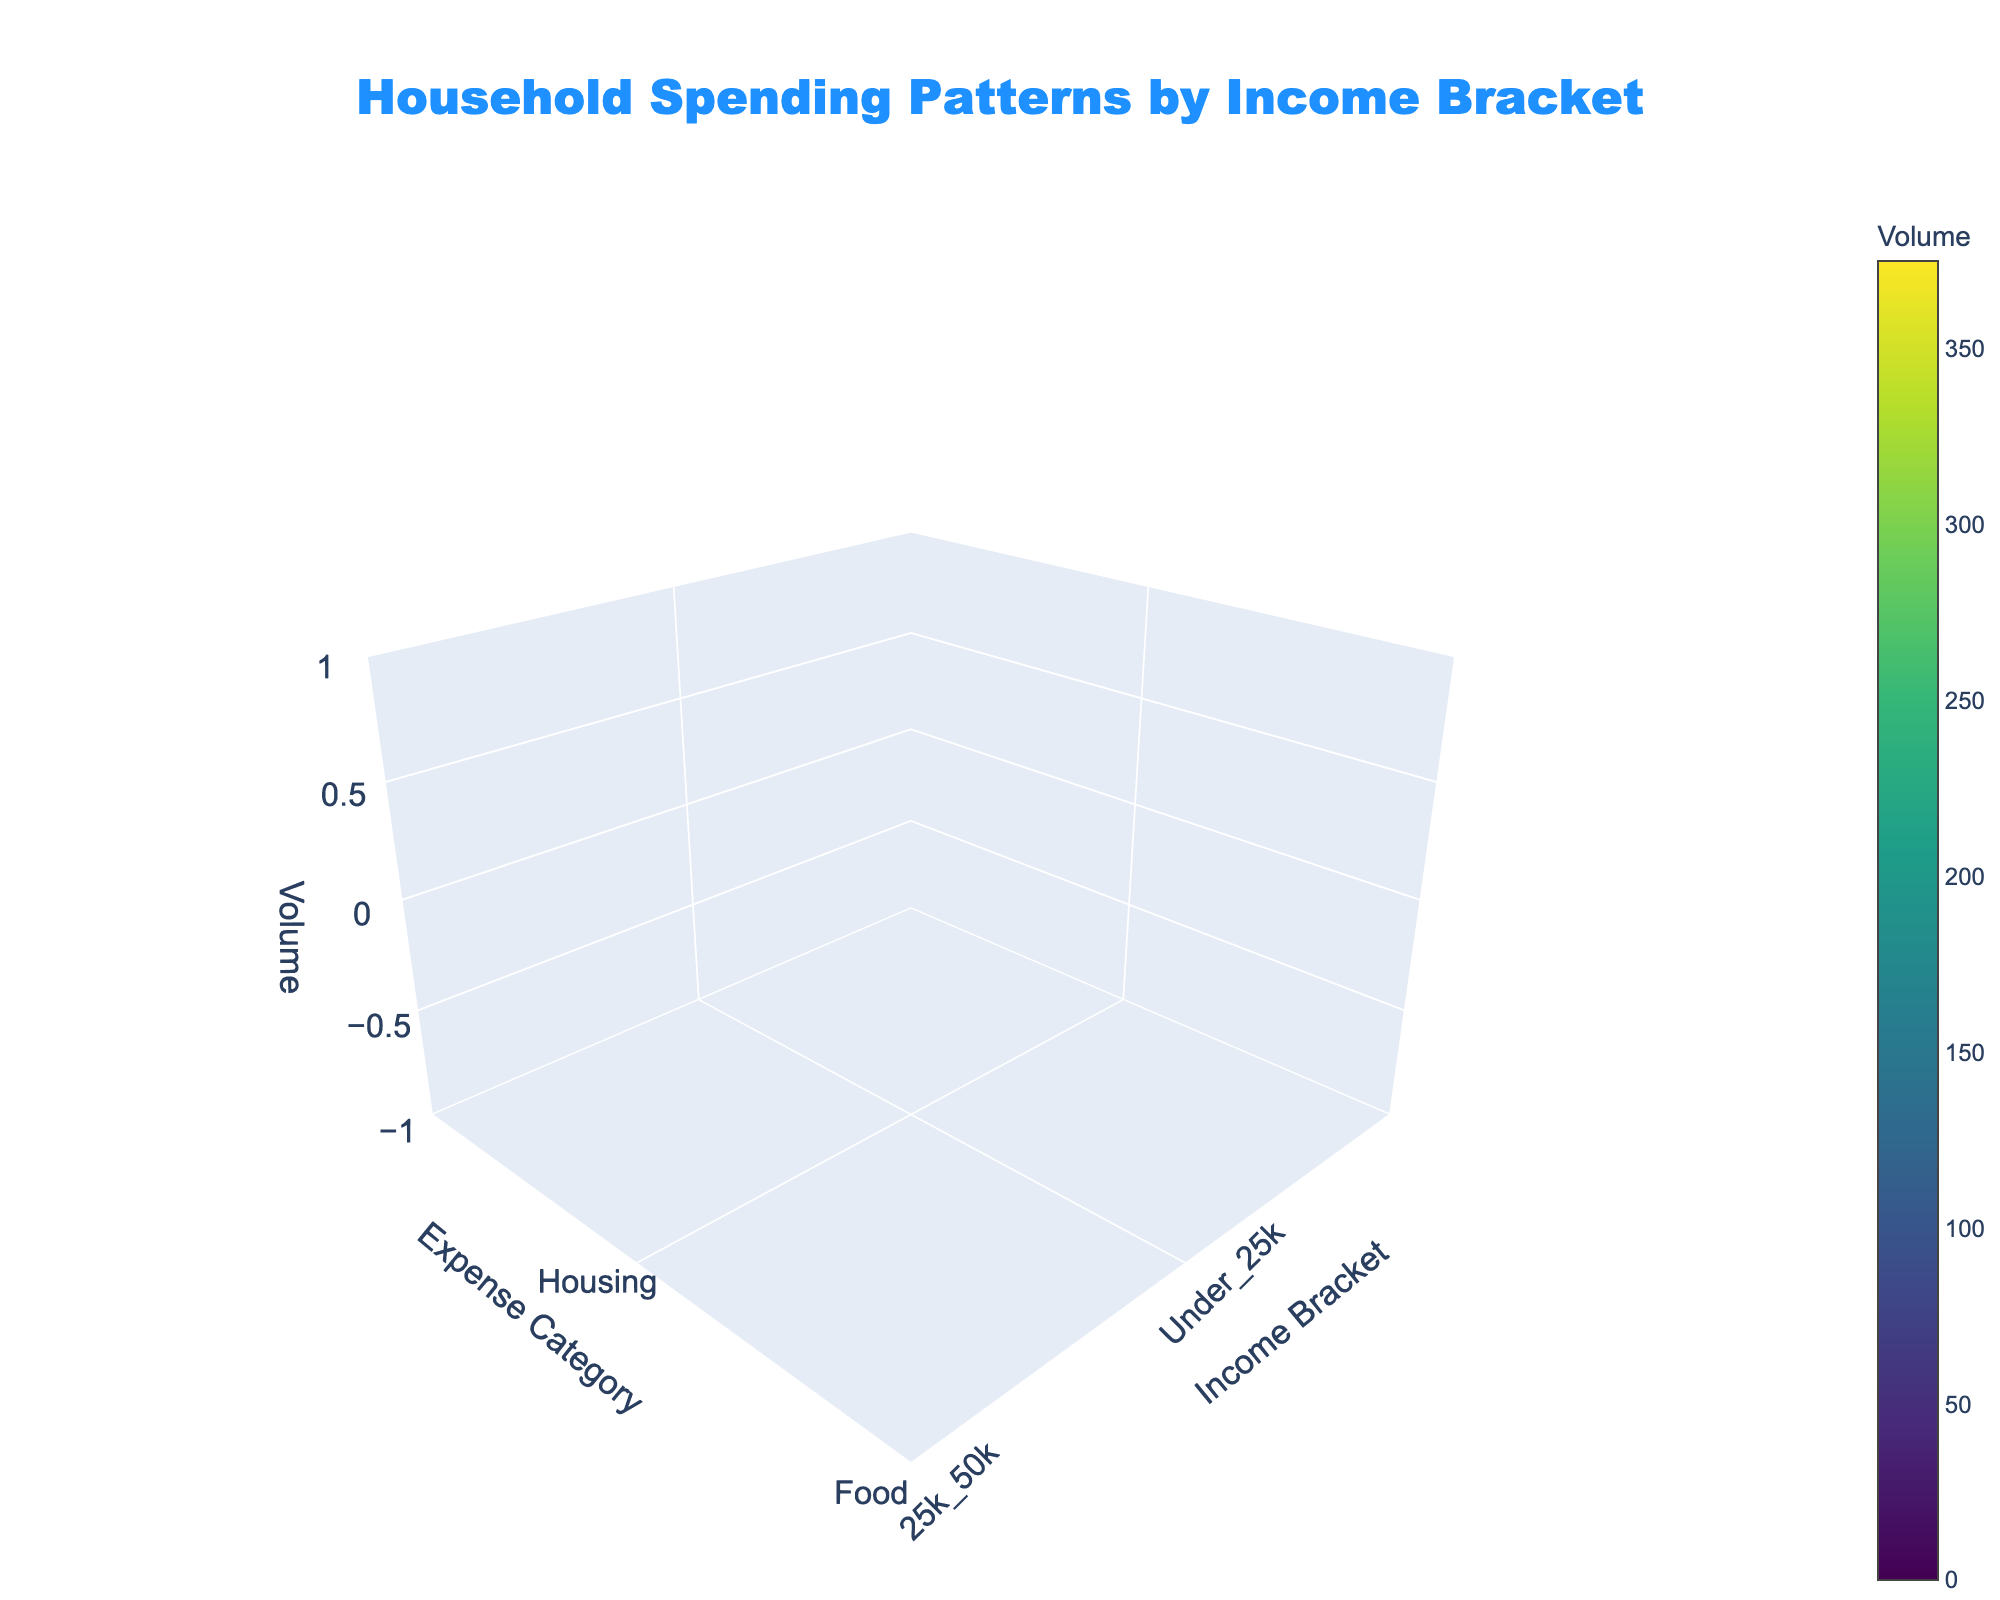What's the title of the figure? The title is usually found at the top of the figure. In this case, it reads "Household Spending Patterns by Income Bracket."
Answer: Household Spending Patterns by Income Bracket What does the colorbar title indicate? The colorbar provides a legend for interpreting the colors in the plot. The title "Volume" indicates it reflects the amount of volume spent on different expenses by income brackets.
Answer: Volume Which income bracket has the highest volume of expenditure on entertainment? By examining the volume data for entertainment across income brackets, the highest value of 375 appears in the "Over_100k" bracket.
Answer: Over_100k Which expense category has the smallest volume for the "Under_25k" income bracket? By checking the volume values for the "Under_25k" income bracket, "Entertainment" and "Savings" both have the smallest value of 14.
Answer: Entertainment, Savings What is the range of housing volumes across different income brackets? By looking at the volume values for "Housing" in all income brackets, they range from 100 (Under_25k) to 300 (Over_100k).
Answer: 100 to 300 What is the average volume of transportation expenses across all income brackets? Summing the values for "Transportation" across all income brackets gives 43 + 75 + 90 + 100 + 120 = 428. Dividing by the number of brackets (5) yields an average of 428 / 5 = 85.6.
Answer: 85.6 How does the volume of savings for the "75k_100k" bracket compare to "Under_25k"? Both values are extracted from the data: "75k_100k" has a savings volume of 200, and "Under_25k" has 14. The "75k_100k" volume is significantly higher.
Answer: 200 vs. 14 What's the sum of volumes for healthcare expenses across all income brackets? Adding the healthcare volumes for all income brackets: 29 + 50 + 75 + 100 + 120 gives a total sum of 374.
Answer: 374 In which income bracket does food occupy the lowest volume? By examining food expenses across all income brackets, the "Over_100k" bracket has the lowest volume of 150.
Answer: Over_100k Which expense category sees the most volume variation across income brackets? By visually comparing volume ranges across categories, "Entertainment" varies from 14 to 375, which is the widest spread.
Answer: Entertainment 